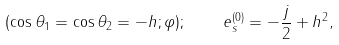Convert formula to latex. <formula><loc_0><loc_0><loc_500><loc_500>( \cos \theta _ { 1 } = \cos \theta _ { 2 } = - h ; \varphi ) ; \quad e _ { s } ^ { ( 0 ) } = - \frac { j } { 2 } + h ^ { 2 } ,</formula> 